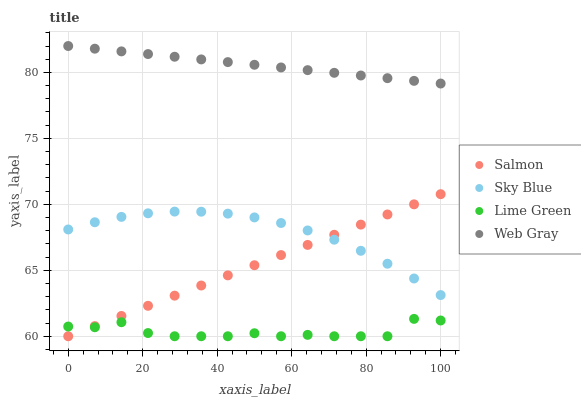Does Lime Green have the minimum area under the curve?
Answer yes or no. Yes. Does Web Gray have the maximum area under the curve?
Answer yes or no. Yes. Does Salmon have the minimum area under the curve?
Answer yes or no. No. Does Salmon have the maximum area under the curve?
Answer yes or no. No. Is Salmon the smoothest?
Answer yes or no. Yes. Is Lime Green the roughest?
Answer yes or no. Yes. Is Web Gray the smoothest?
Answer yes or no. No. Is Web Gray the roughest?
Answer yes or no. No. Does Salmon have the lowest value?
Answer yes or no. Yes. Does Web Gray have the lowest value?
Answer yes or no. No. Does Web Gray have the highest value?
Answer yes or no. Yes. Does Salmon have the highest value?
Answer yes or no. No. Is Lime Green less than Sky Blue?
Answer yes or no. Yes. Is Web Gray greater than Sky Blue?
Answer yes or no. Yes. Does Lime Green intersect Salmon?
Answer yes or no. Yes. Is Lime Green less than Salmon?
Answer yes or no. No. Is Lime Green greater than Salmon?
Answer yes or no. No. Does Lime Green intersect Sky Blue?
Answer yes or no. No. 